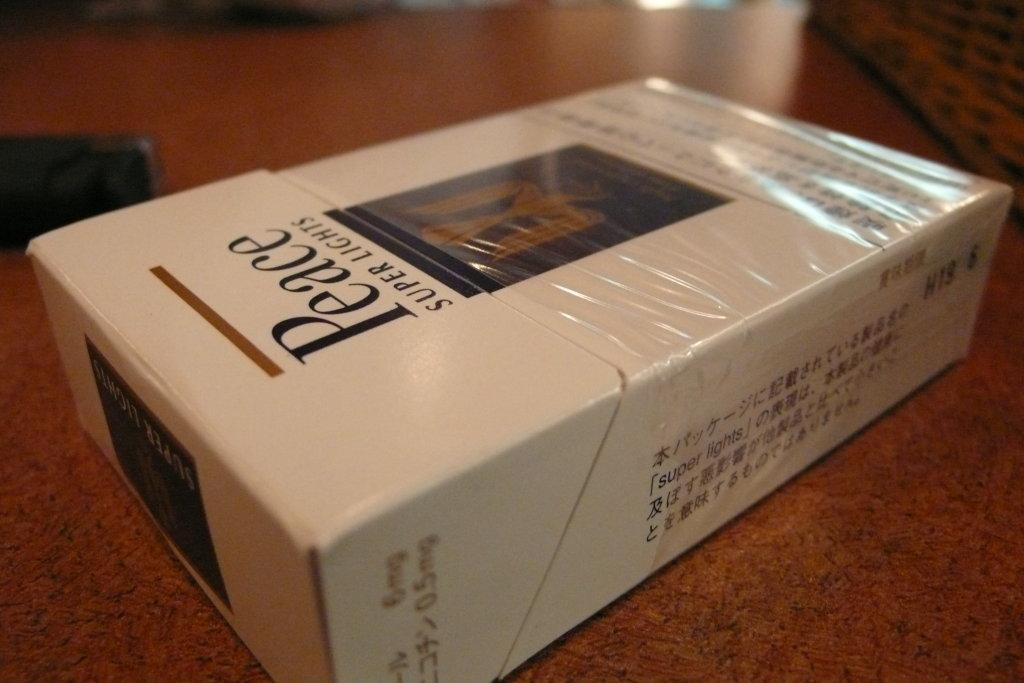<image>
Render a clear and concise summary of the photo. Super Lights cigarettes are in a box with the word, "Peace", in large letters on the front of the box. 